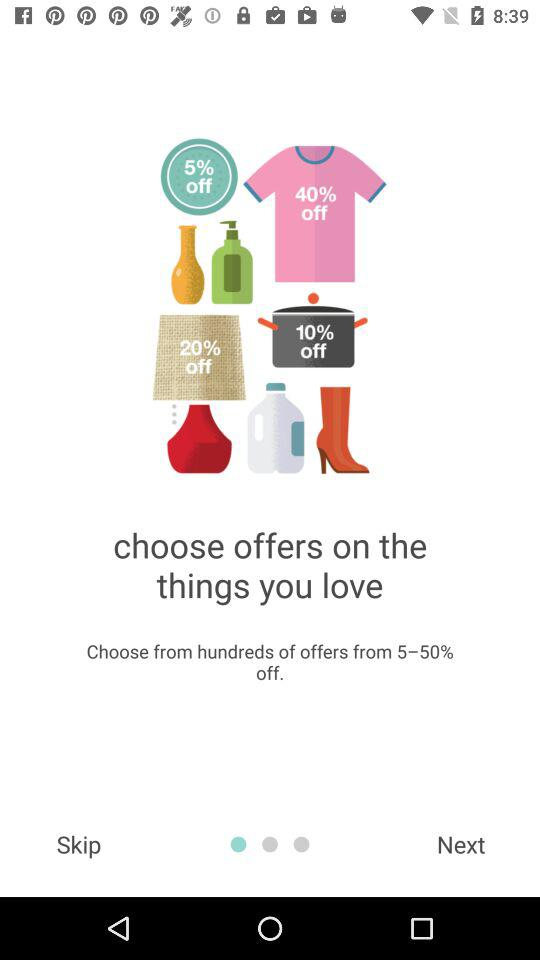How many percent off is the highest offer?
Answer the question using a single word or phrase. 50% 